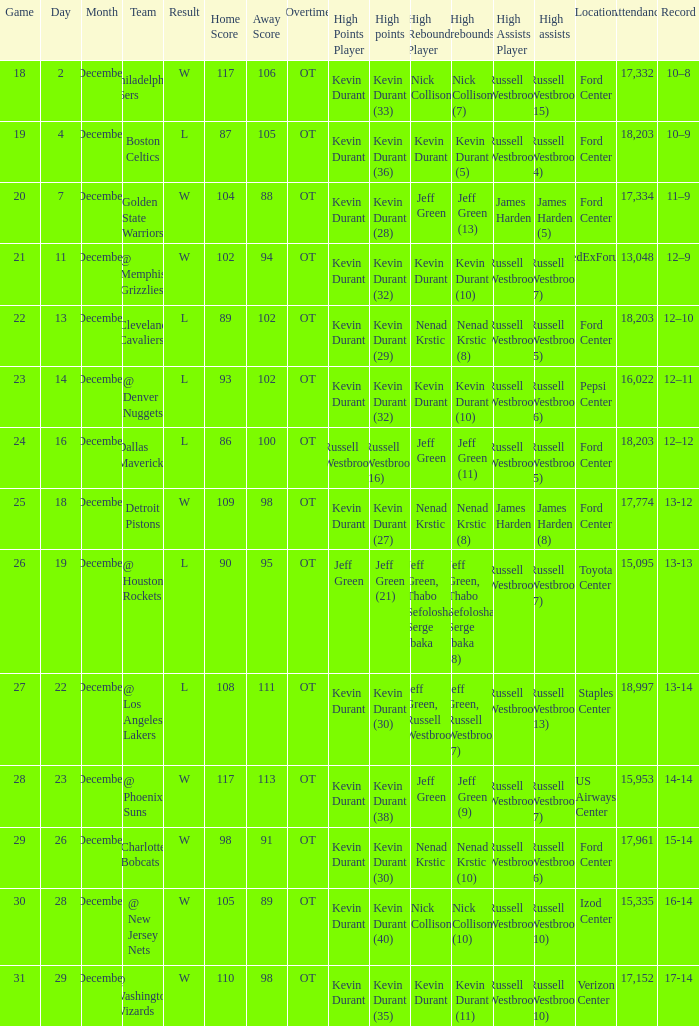What location attendance has russell westbrook (5) as high assists and nenad krstic (8) as high rebounds? Ford Center 18,203. 